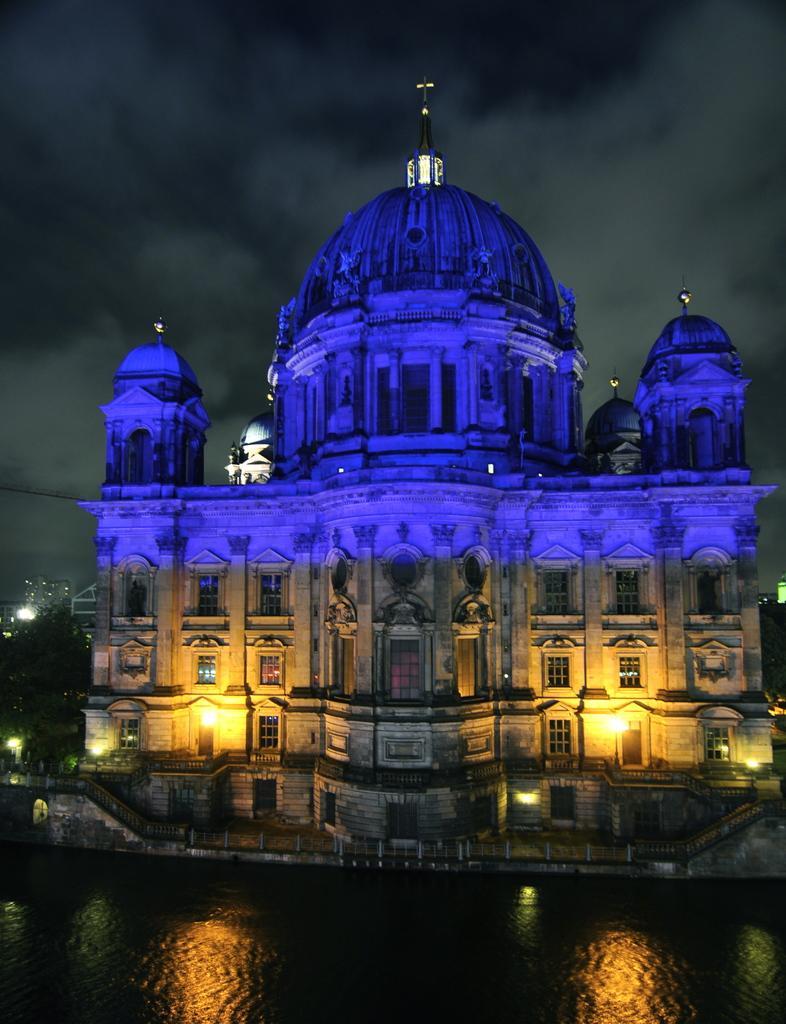Please provide a concise description of this image. In this image we can see a building with windows and lights, in front of the building there is some water, in the background we can see the sky. 